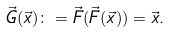<formula> <loc_0><loc_0><loc_500><loc_500>\vec { G } ( \vec { x } ) \colon = \vec { F } ( \vec { F } ( \vec { x } ) ) = \vec { x } .</formula> 